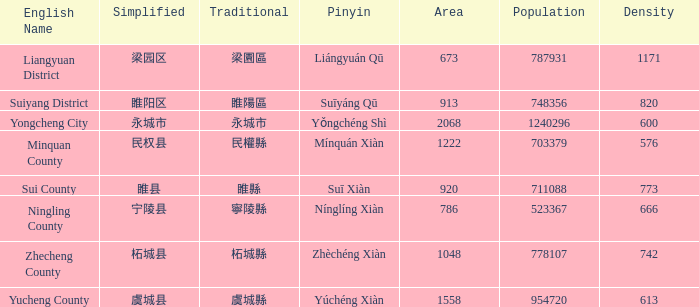What is the classic form for 永城市? 永城市. 